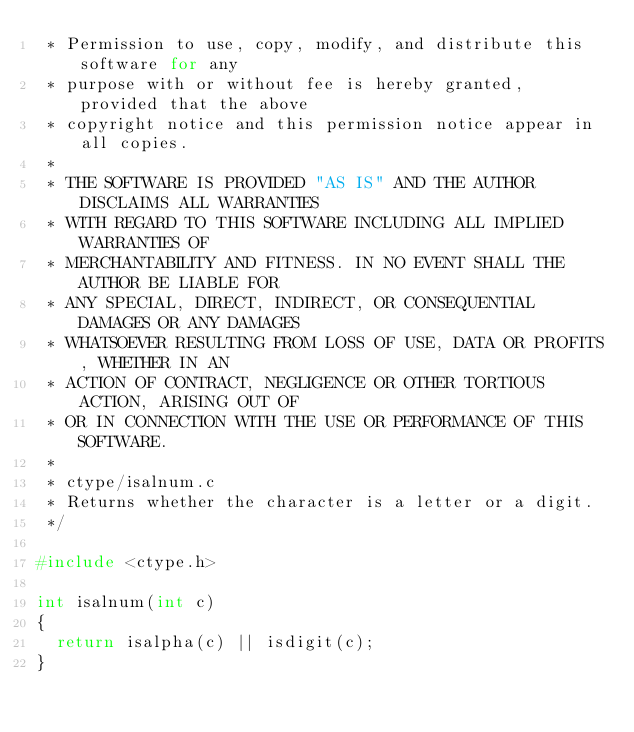Convert code to text. <code><loc_0><loc_0><loc_500><loc_500><_C_> * Permission to use, copy, modify, and distribute this software for any
 * purpose with or without fee is hereby granted, provided that the above
 * copyright notice and this permission notice appear in all copies.
 *
 * THE SOFTWARE IS PROVIDED "AS IS" AND THE AUTHOR DISCLAIMS ALL WARRANTIES
 * WITH REGARD TO THIS SOFTWARE INCLUDING ALL IMPLIED WARRANTIES OF
 * MERCHANTABILITY AND FITNESS. IN NO EVENT SHALL THE AUTHOR BE LIABLE FOR
 * ANY SPECIAL, DIRECT, INDIRECT, OR CONSEQUENTIAL DAMAGES OR ANY DAMAGES
 * WHATSOEVER RESULTING FROM LOSS OF USE, DATA OR PROFITS, WHETHER IN AN
 * ACTION OF CONTRACT, NEGLIGENCE OR OTHER TORTIOUS ACTION, ARISING OUT OF
 * OR IN CONNECTION WITH THE USE OR PERFORMANCE OF THIS SOFTWARE.
 *
 * ctype/isalnum.c
 * Returns whether the character is a letter or a digit.
 */

#include <ctype.h>

int isalnum(int c)
{
	return isalpha(c) || isdigit(c);
}
</code> 